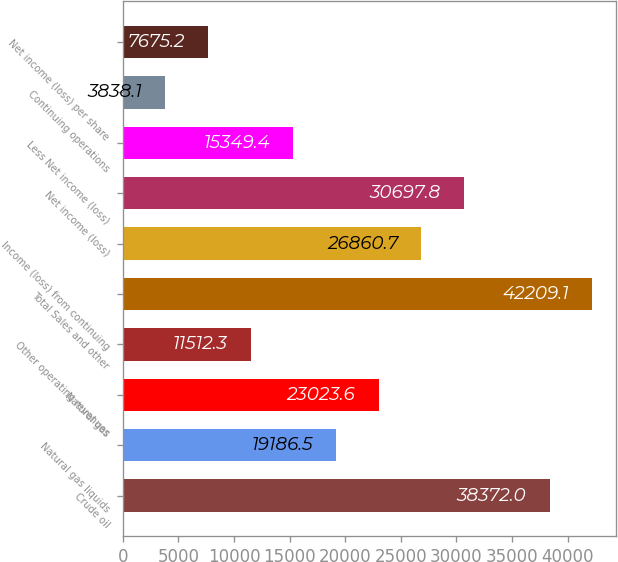Convert chart to OTSL. <chart><loc_0><loc_0><loc_500><loc_500><bar_chart><fcel>Crude oil<fcel>Natural gas liquids<fcel>Natural gas<fcel>Other operating revenues<fcel>Total Sales and other<fcel>Income (loss) from continuing<fcel>Net income (loss)<fcel>Less Net income (loss)<fcel>Continuing operations<fcel>Net income (loss) per share<nl><fcel>38372<fcel>19186.5<fcel>23023.6<fcel>11512.3<fcel>42209.1<fcel>26860.7<fcel>30697.8<fcel>15349.4<fcel>3838.1<fcel>7675.2<nl></chart> 